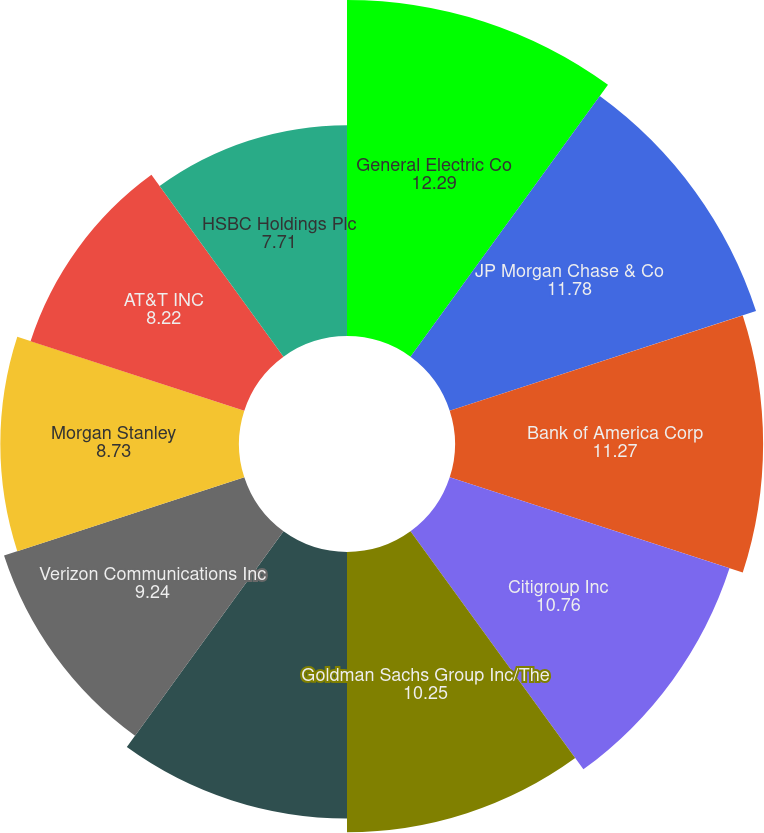Convert chart. <chart><loc_0><loc_0><loc_500><loc_500><pie_chart><fcel>General Electric Co<fcel>JP Morgan Chase & Co<fcel>Bank of America Corp<fcel>Citigroup Inc<fcel>Goldman Sachs Group Inc/The<fcel>Wells Fargo & Co<fcel>Verizon Communications Inc<fcel>Morgan Stanley<fcel>AT&T INC<fcel>HSBC Holdings Plc<nl><fcel>12.29%<fcel>11.78%<fcel>11.27%<fcel>10.76%<fcel>10.25%<fcel>9.75%<fcel>9.24%<fcel>8.73%<fcel>8.22%<fcel>7.71%<nl></chart> 